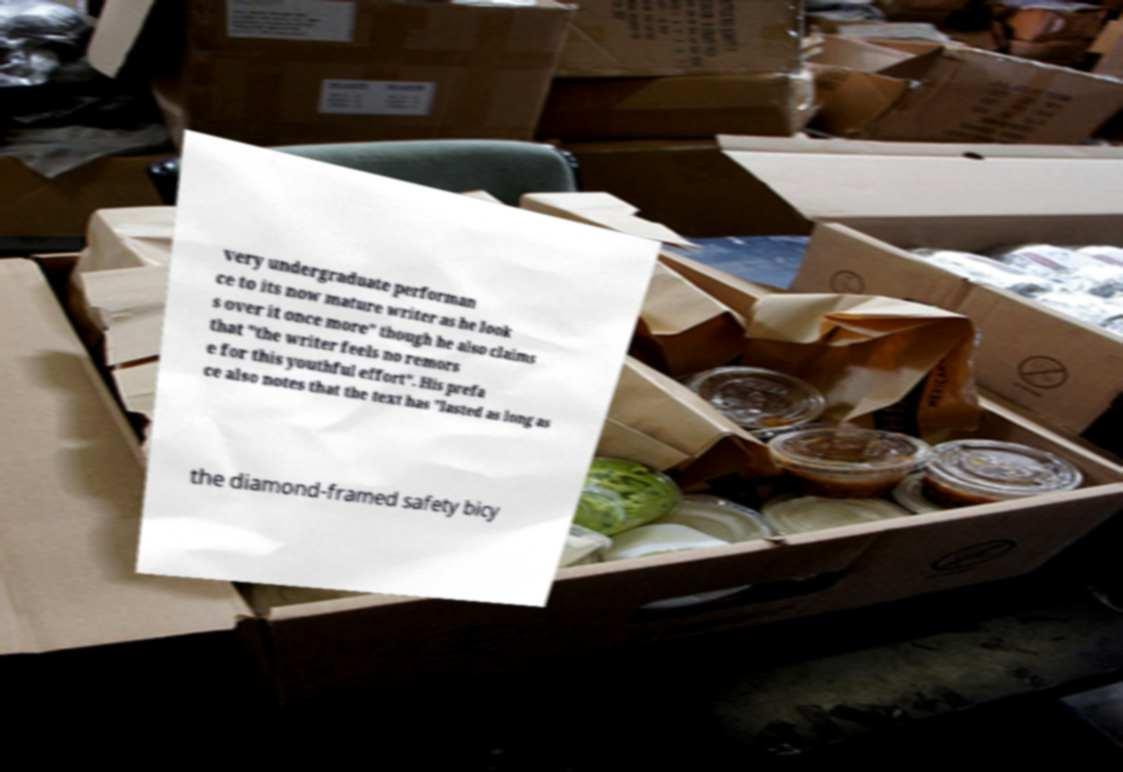Please read and relay the text visible in this image. What does it say? very undergraduate performan ce to its now mature writer as he look s over it once more" though he also claims that "the writer feels no remors e for this youthful effort". His prefa ce also notes that the text has "lasted as long as the diamond-framed safety bicy 